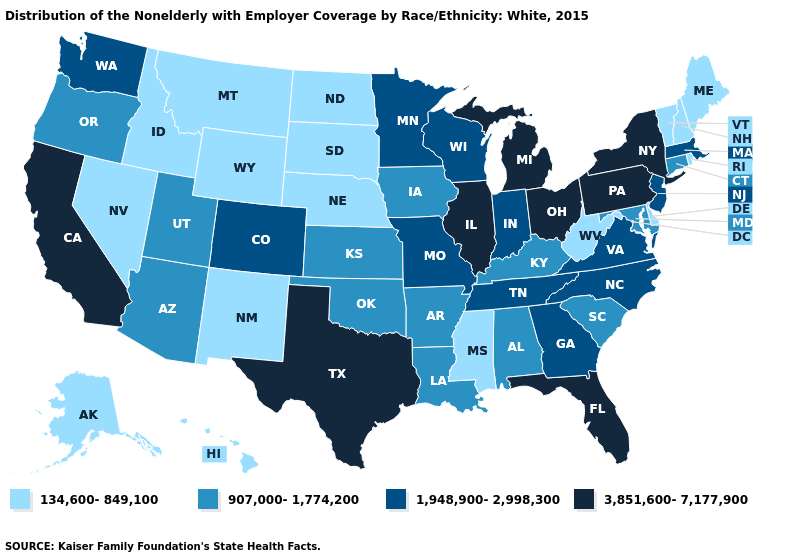Does Florida have the highest value in the South?
Give a very brief answer. Yes. What is the value of Nevada?
Quick response, please. 134,600-849,100. Among the states that border Rhode Island , which have the highest value?
Keep it brief. Massachusetts. What is the value of Ohio?
Keep it brief. 3,851,600-7,177,900. What is the lowest value in the USA?
Concise answer only. 134,600-849,100. Name the states that have a value in the range 134,600-849,100?
Quick response, please. Alaska, Delaware, Hawaii, Idaho, Maine, Mississippi, Montana, Nebraska, Nevada, New Hampshire, New Mexico, North Dakota, Rhode Island, South Dakota, Vermont, West Virginia, Wyoming. Name the states that have a value in the range 907,000-1,774,200?
Give a very brief answer. Alabama, Arizona, Arkansas, Connecticut, Iowa, Kansas, Kentucky, Louisiana, Maryland, Oklahoma, Oregon, South Carolina, Utah. Is the legend a continuous bar?
Give a very brief answer. No. Name the states that have a value in the range 1,948,900-2,998,300?
Short answer required. Colorado, Georgia, Indiana, Massachusetts, Minnesota, Missouri, New Jersey, North Carolina, Tennessee, Virginia, Washington, Wisconsin. Among the states that border Florida , does Georgia have the highest value?
Short answer required. Yes. Does the map have missing data?
Answer briefly. No. Does Washington have the lowest value in the USA?
Be succinct. No. Which states have the lowest value in the USA?
Quick response, please. Alaska, Delaware, Hawaii, Idaho, Maine, Mississippi, Montana, Nebraska, Nevada, New Hampshire, New Mexico, North Dakota, Rhode Island, South Dakota, Vermont, West Virginia, Wyoming. Does Delaware have the lowest value in the USA?
Quick response, please. Yes. What is the lowest value in the MidWest?
Answer briefly. 134,600-849,100. 